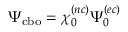<formula> <loc_0><loc_0><loc_500><loc_500>\Psi _ { c b o } = \chi _ { 0 } ^ { ( n c ) } \Psi _ { 0 } ^ { ( e c ) }</formula> 